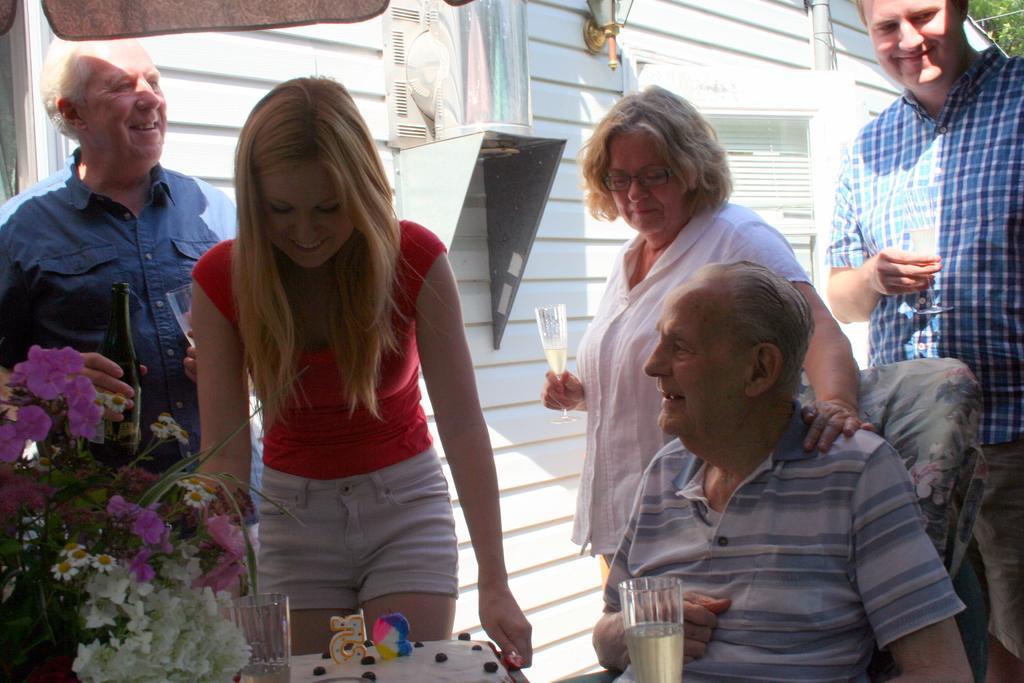Describe this image in one or two sentences. In the left side a beautiful girl is standing, she wore a red color top. In the left side there are flower plants and in the right side an old man is sitting. Right side a man is standing and holding a wine glass in his hands. 